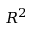Convert formula to latex. <formula><loc_0><loc_0><loc_500><loc_500>R ^ { 2 }</formula> 